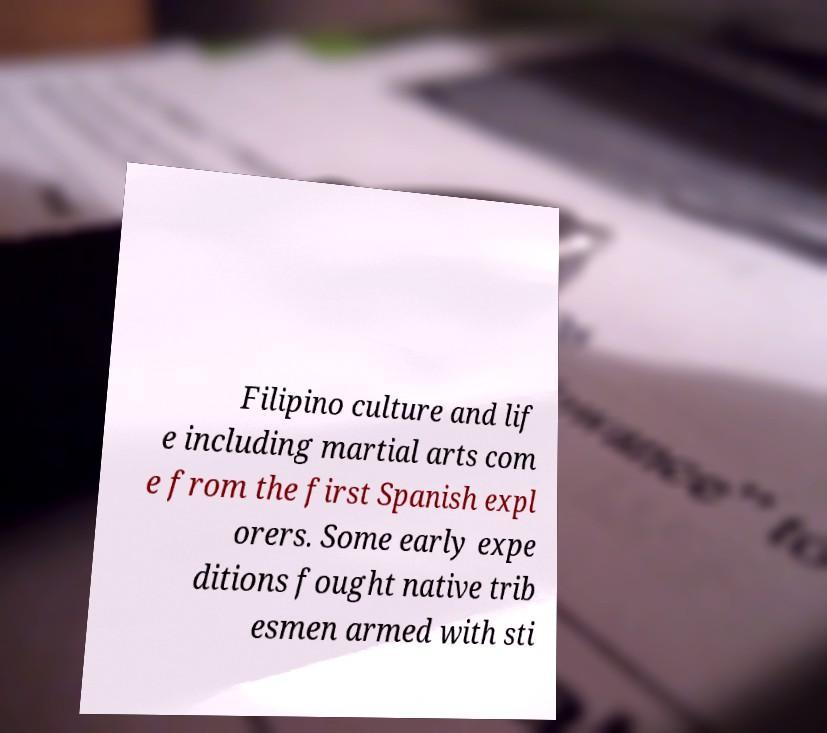Can you accurately transcribe the text from the provided image for me? Filipino culture and lif e including martial arts com e from the first Spanish expl orers. Some early expe ditions fought native trib esmen armed with sti 